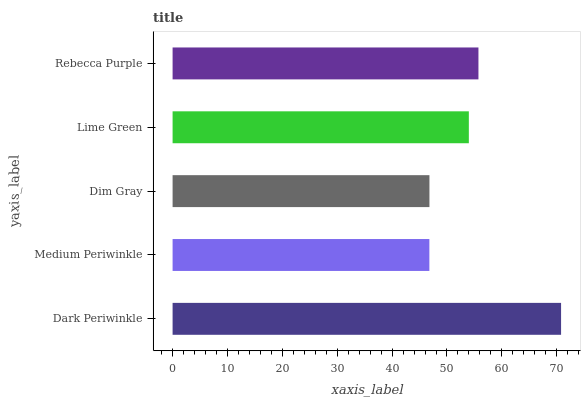Is Medium Periwinkle the minimum?
Answer yes or no. Yes. Is Dark Periwinkle the maximum?
Answer yes or no. Yes. Is Dim Gray the minimum?
Answer yes or no. No. Is Dim Gray the maximum?
Answer yes or no. No. Is Dim Gray greater than Medium Periwinkle?
Answer yes or no. Yes. Is Medium Periwinkle less than Dim Gray?
Answer yes or no. Yes. Is Medium Periwinkle greater than Dim Gray?
Answer yes or no. No. Is Dim Gray less than Medium Periwinkle?
Answer yes or no. No. Is Lime Green the high median?
Answer yes or no. Yes. Is Lime Green the low median?
Answer yes or no. Yes. Is Dim Gray the high median?
Answer yes or no. No. Is Dim Gray the low median?
Answer yes or no. No. 